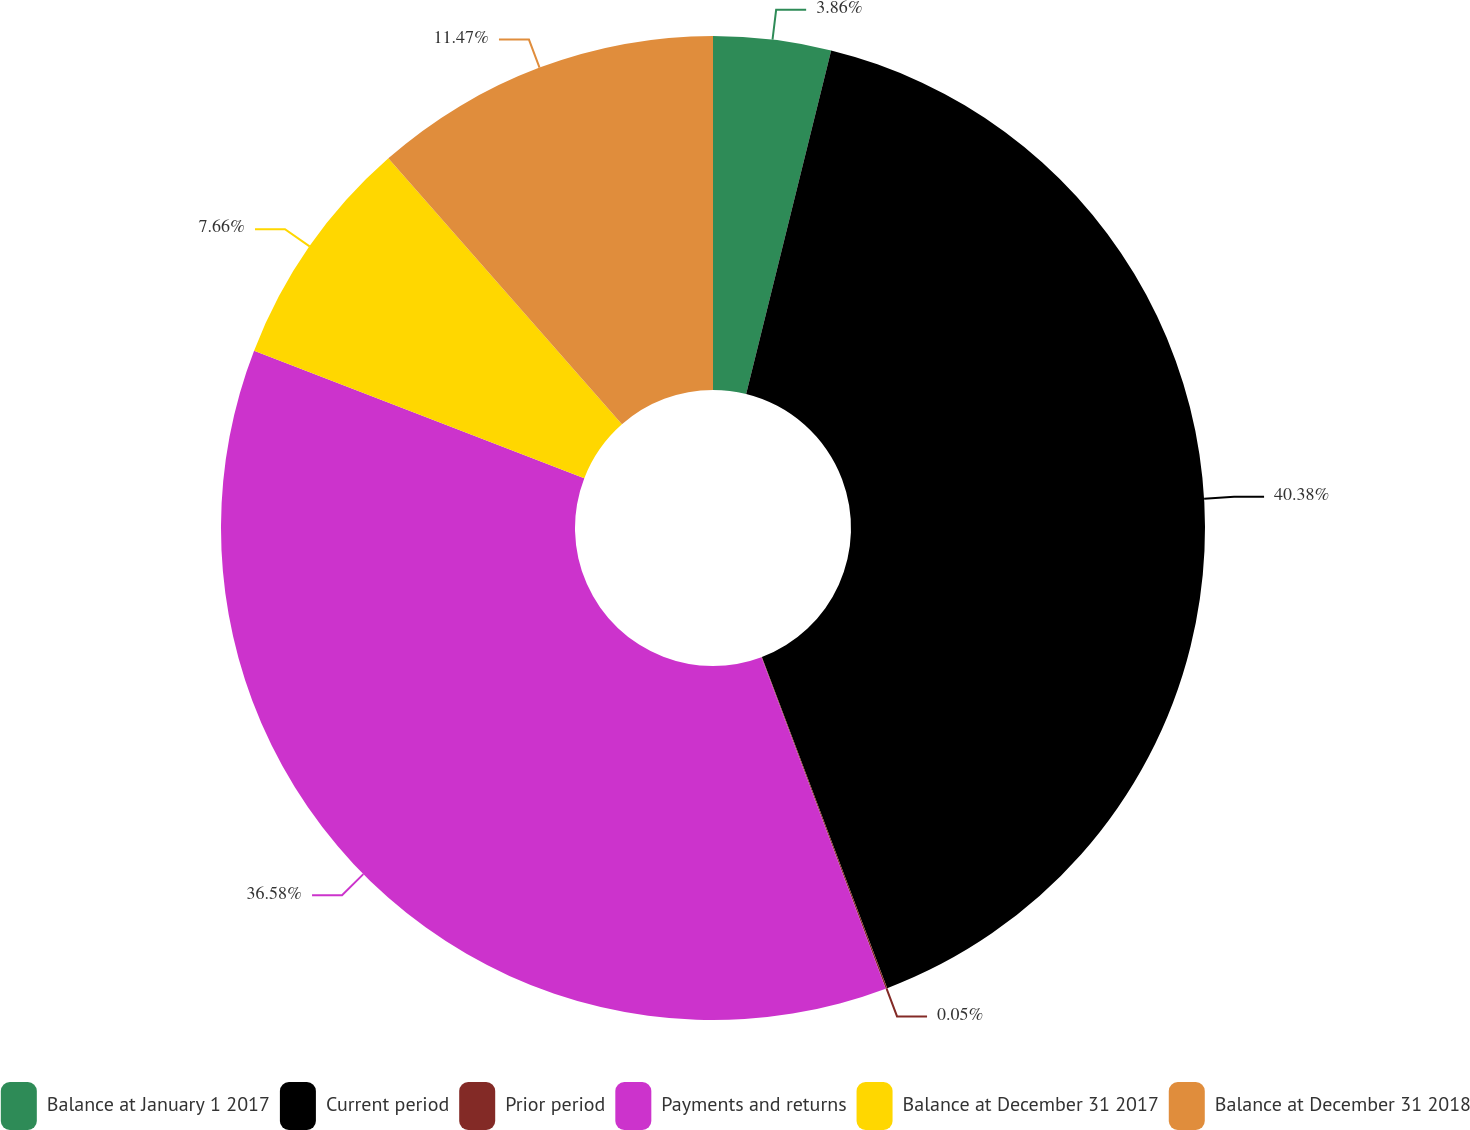<chart> <loc_0><loc_0><loc_500><loc_500><pie_chart><fcel>Balance at January 1 2017<fcel>Current period<fcel>Prior period<fcel>Payments and returns<fcel>Balance at December 31 2017<fcel>Balance at December 31 2018<nl><fcel>3.86%<fcel>40.38%<fcel>0.05%<fcel>36.58%<fcel>7.66%<fcel>11.47%<nl></chart> 